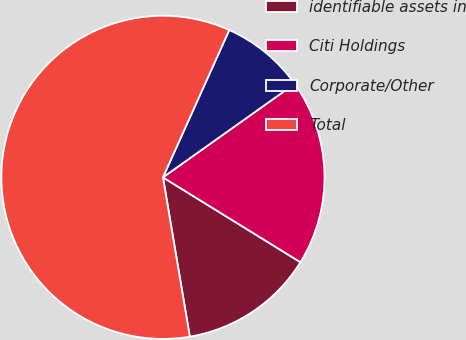Convert chart. <chart><loc_0><loc_0><loc_500><loc_500><pie_chart><fcel>identifiable assets in<fcel>Citi Holdings<fcel>Corporate/Other<fcel>Total<nl><fcel>13.54%<fcel>18.63%<fcel>8.44%<fcel>59.39%<nl></chart> 